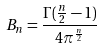<formula> <loc_0><loc_0><loc_500><loc_500>B _ { n } = \frac { \Gamma ( \frac { n } { 2 } - 1 ) } { 4 \pi ^ { \frac { n } { 2 } } }</formula> 